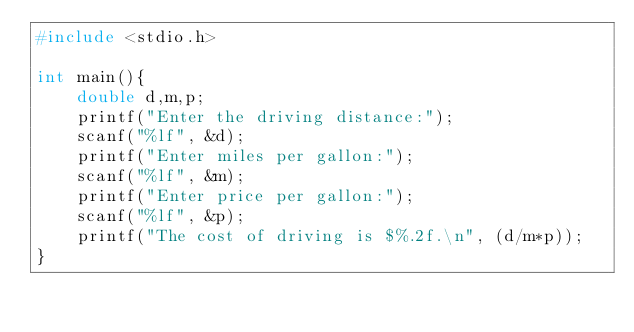<code> <loc_0><loc_0><loc_500><loc_500><_C_>#include <stdio.h>

int main(){
    double d,m,p;
    printf("Enter the driving distance:");
    scanf("%lf", &d);
    printf("Enter miles per gallon:");
    scanf("%lf", &m);
    printf("Enter price per gallon:");
    scanf("%lf", &p);
    printf("The cost of driving is $%.2f.\n", (d/m*p));
}</code> 